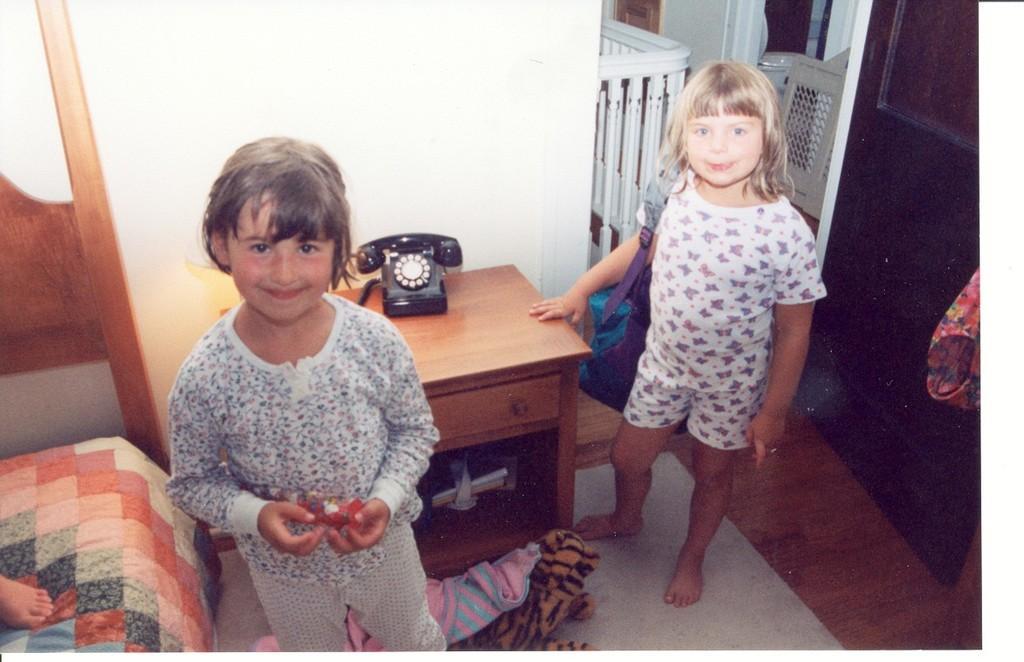Can you describe this image briefly? In this image there are two girls who are standing beside each other. There is a table in front of them on which there is a telephone. At the back side there is a wall. To the left side there is a bed on which a person is sitting. 